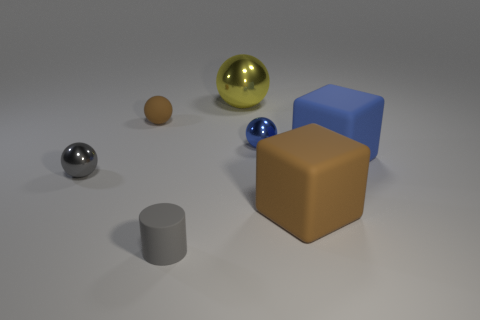Is the size of the gray thing that is on the left side of the brown rubber sphere the same as the yellow metallic thing behind the large brown object? No, the gray sphere on the left side is smaller in diameter than the yellow metallic sphere located behind the large brown cube. The latter appears to be roughly twice the size of the former when comparing their relative sizes visually in this image. 